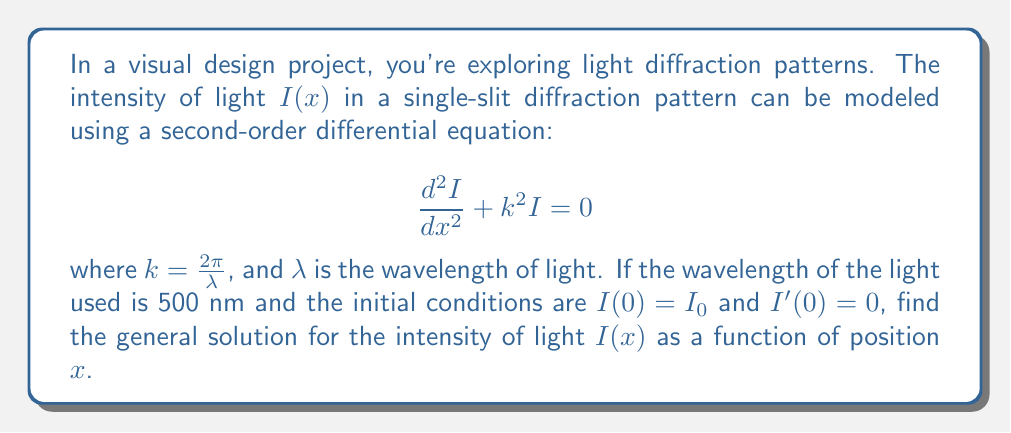Teach me how to tackle this problem. To solve this problem, we'll follow these steps:

1) First, we recognize this as a second-order linear homogeneous differential equation with constant coefficients. The general form of the solution is:

   $$ I(x) = A \cos(kx) + B \sin(kx) $$

   where $A$ and $B$ are constants to be determined from the initial conditions.

2) We're given that $k = \frac{2\pi}{\lambda}$. Let's calculate this value:

   $$ k = \frac{2\pi}{\lambda} = \frac{2\pi}{500 \times 10^{-9}} = 1.257 \times 10^7 \text{ m}^{-1} $$

3) Now, let's apply the initial conditions:

   a) $I(0) = I_0$:
      $I(0) = A \cos(0) + B \sin(0) = A = I_0$

   b) $I'(0) = 0$:
      $I'(x) = -Ak \sin(kx) + Bk \cos(kx)$
      $I'(0) = -Ak \sin(0) + Bk \cos(0) = Bk = 0$
      Therefore, $B = 0$

4) Substituting these values back into our general solution:

   $$ I(x) = I_0 \cos(kx) $$

5) Finally, we can write our solution with the calculated value of $k$:

   $$ I(x) = I_0 \cos(1.257 \times 10^7 x) $$

This equation represents the intensity of light as a function of position $x$ in the diffraction pattern.
Answer: $$ I(x) = I_0 \cos(1.257 \times 10^7 x) $$
where $I_0$ is the initial intensity at $x = 0$. 